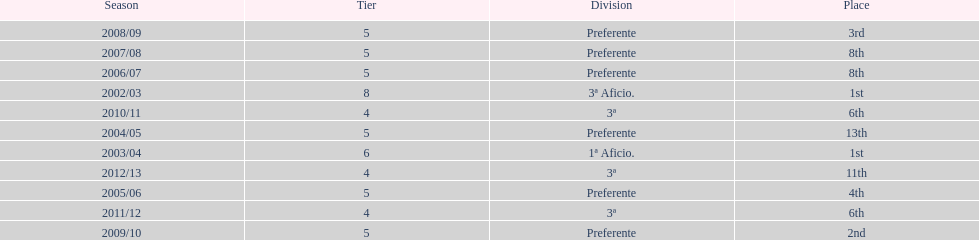How many seasons did internacional de madrid cf play in the preferente division? 6. 